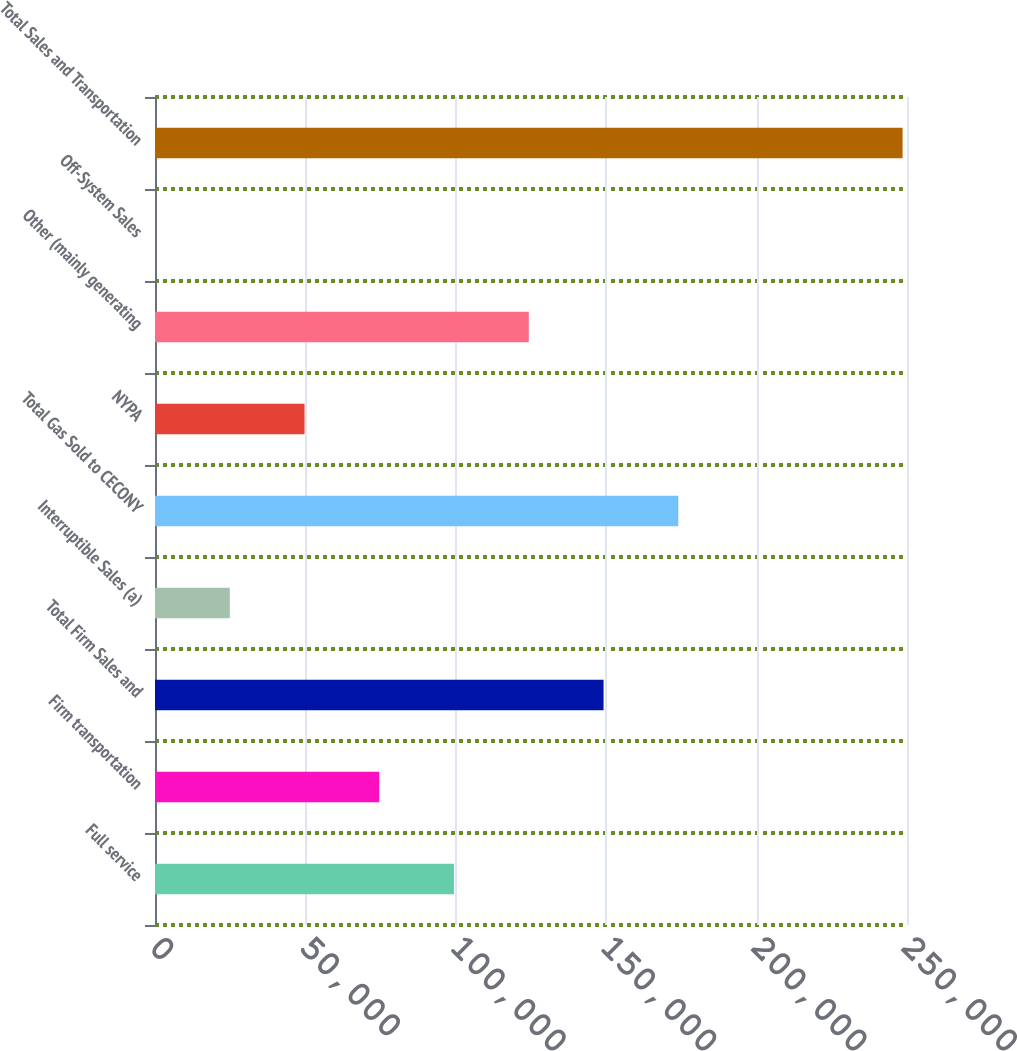Convert chart to OTSL. <chart><loc_0><loc_0><loc_500><loc_500><bar_chart><fcel>Full service<fcel>Firm transportation<fcel>Total Firm Sales and<fcel>Interruptible Sales (a)<fcel>Total Gas Sold to CECONY<fcel>NYPA<fcel>Other (mainly generating<fcel>Off-System Sales<fcel>Total Sales and Transportation<nl><fcel>99418.2<fcel>74565.4<fcel>149124<fcel>24859.8<fcel>173977<fcel>49712.6<fcel>124271<fcel>7<fcel>248535<nl></chart> 